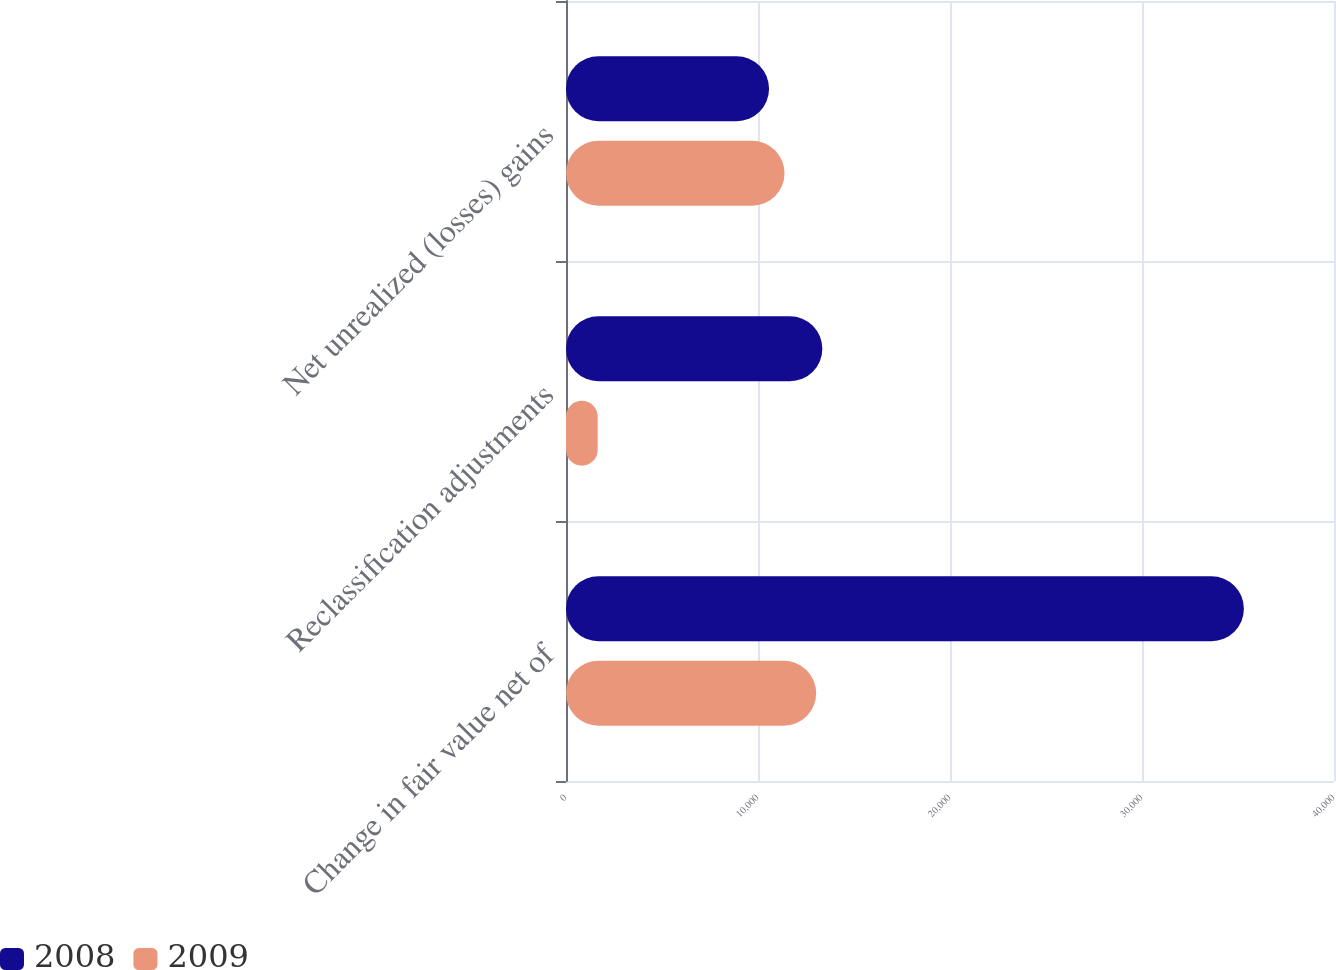Convert chart to OTSL. <chart><loc_0><loc_0><loc_500><loc_500><stacked_bar_chart><ecel><fcel>Change in fair value net of<fcel>Reclassification adjustments<fcel>Net unrealized (losses) gains<nl><fcel>2008<fcel>35307<fcel>13351<fcel>10575<nl><fcel>2009<fcel>13030<fcel>1649<fcel>11381<nl></chart> 